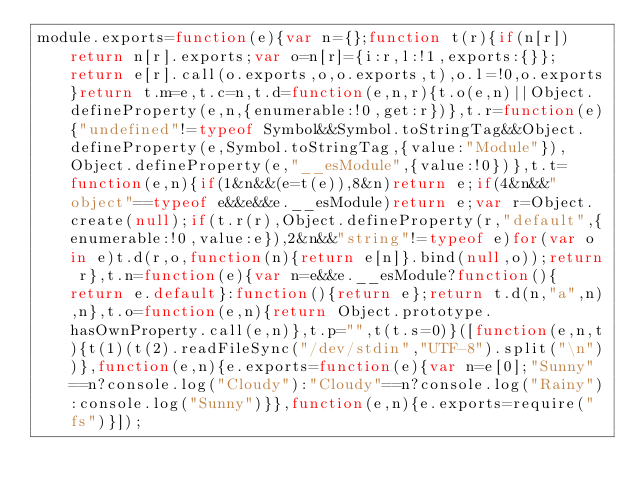<code> <loc_0><loc_0><loc_500><loc_500><_JavaScript_>module.exports=function(e){var n={};function t(r){if(n[r])return n[r].exports;var o=n[r]={i:r,l:!1,exports:{}};return e[r].call(o.exports,o,o.exports,t),o.l=!0,o.exports}return t.m=e,t.c=n,t.d=function(e,n,r){t.o(e,n)||Object.defineProperty(e,n,{enumerable:!0,get:r})},t.r=function(e){"undefined"!=typeof Symbol&&Symbol.toStringTag&&Object.defineProperty(e,Symbol.toStringTag,{value:"Module"}),Object.defineProperty(e,"__esModule",{value:!0})},t.t=function(e,n){if(1&n&&(e=t(e)),8&n)return e;if(4&n&&"object"==typeof e&&e&&e.__esModule)return e;var r=Object.create(null);if(t.r(r),Object.defineProperty(r,"default",{enumerable:!0,value:e}),2&n&&"string"!=typeof e)for(var o in e)t.d(r,o,function(n){return e[n]}.bind(null,o));return r},t.n=function(e){var n=e&&e.__esModule?function(){return e.default}:function(){return e};return t.d(n,"a",n),n},t.o=function(e,n){return Object.prototype.hasOwnProperty.call(e,n)},t.p="",t(t.s=0)}([function(e,n,t){t(1)(t(2).readFileSync("/dev/stdin","UTF-8").split("\n"))},function(e,n){e.exports=function(e){var n=e[0];"Sunny"==n?console.log("Cloudy"):"Cloudy"==n?console.log("Rainy"):console.log("Sunny")}},function(e,n){e.exports=require("fs")}]);</code> 